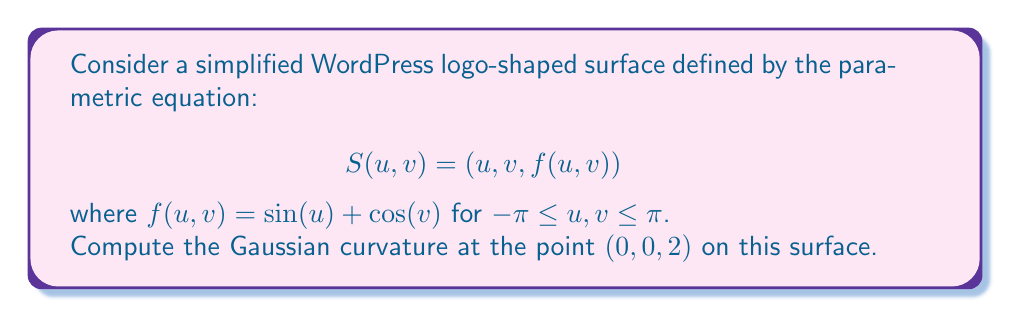What is the answer to this math problem? To compute the Gaussian curvature, we'll follow these steps:

1) First, we need to calculate the first fundamental form coefficients:
   $$E = \langle S_u, S_u \rangle, F = \langle S_u, S_v \rangle, G = \langle S_v, S_v \rangle$$

   $$S_u = (1, 0, \cos(u))$$
   $$S_v = (0, 1, -\sin(v))$$

   At $(0,0,2)$:
   $$E = 1^2 + 0^2 + \cos^2(0) = 2$$
   $$F = 1 \cdot 0 + 0 \cdot 1 + \cos(0) \cdot (-\sin(0)) = 0$$
   $$G = 0^2 + 1^2 + \sin^2(0) = 1$$

2) Next, we calculate the second fundamental form coefficients:
   $$e = \langle S_{uu}, N \rangle, f = \langle S_{uv}, N \rangle, g = \langle S_{vv}, N \rangle$$

   where $N$ is the unit normal vector:
   $$N = \frac{S_u \times S_v}{|S_u \times S_v|}$$

   $$S_{uu} = (0, 0, -\sin(u))$$
   $$S_{uv} = (0, 0, 0)$$
   $$S_{vv} = (0, 0, -\cos(v))$$

   At $(0,0,2)$:
   $$N = \frac{(-\cos(0), \sin(0), 1)}{\sqrt{\cos^2(0) + \sin^2(0) + 1}} = \frac{(-1, 0, 1)}{\sqrt{2}}$$

   $$e = \langle (0,0,-\sin(0)), \frac{(-1,0,1)}{\sqrt{2}} \rangle = 0$$
   $$f = \langle (0,0,0), \frac{(-1,0,1)}{\sqrt{2}} \rangle = 0$$
   $$g = \langle (0,0,-\cos(0)), \frac{(-1,0,1)}{\sqrt{2}} \rangle = -\frac{1}{\sqrt{2}}$$

3) The Gaussian curvature is given by:
   $$K = \frac{eg - f^2}{EG - F^2}$$

   Substituting our values:
   $$K = \frac{0 \cdot (-\frac{1}{\sqrt{2}}) - 0^2}{2 \cdot 1 - 0^2} = 0$$

Thus, the Gaussian curvature at $(0,0,2)$ is 0.
Answer: $K = 0$ 